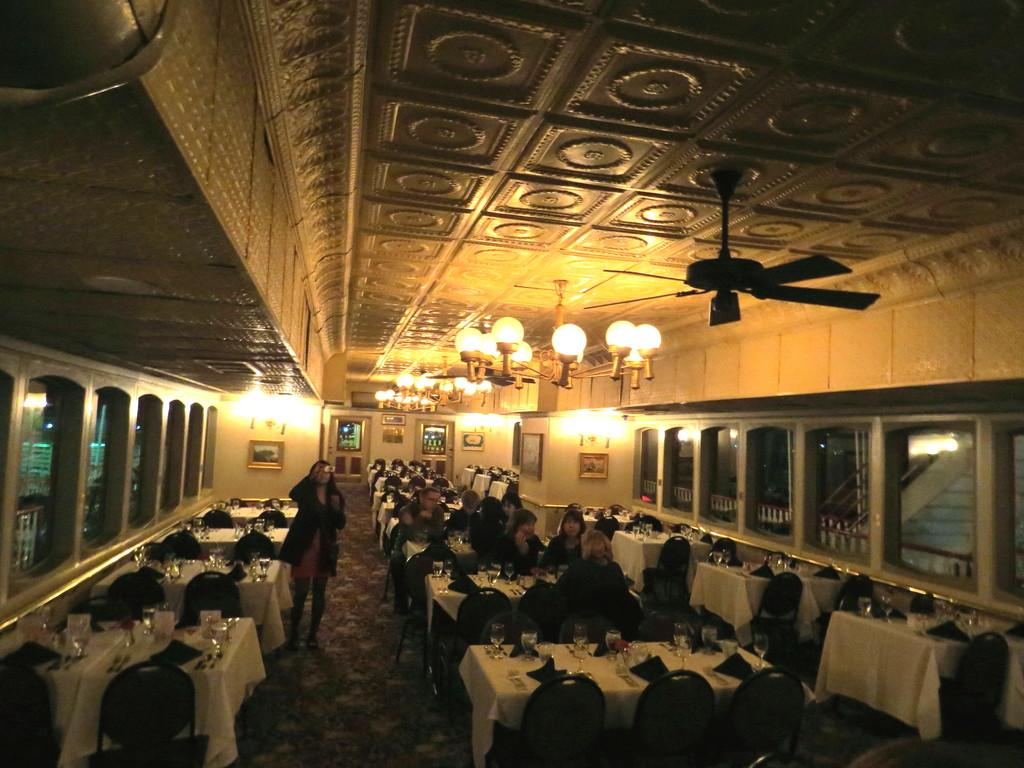What are the people in the image doing? The people in the image are sitting on chairs near tables. What type of lighting is present in the image? There are chandeliers in the image. What type of air circulation is present in the image? There is a ceiling fan in the image. What type of decorations are on the wall in the image? There are photo frames on the wall. What type of windows are present in the image? There are glass windows in the image. What type of record is being played on the record player in the image? There is no record player present in the image. What type of toothbrush is being used by the person in the image? There is no toothbrush present in the image. 